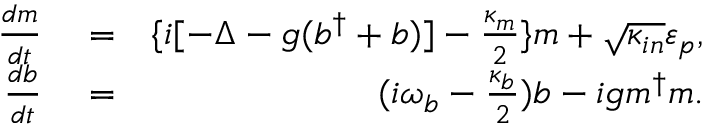<formula> <loc_0><loc_0><loc_500><loc_500>\begin{array} { r l r } { \frac { d m } { d t } } & = } & { \{ i [ - \Delta - g ( b ^ { \dagger } + b ) ] - \frac { \kappa _ { m } } { 2 } \} m + \sqrt { \kappa _ { i n } } \varepsilon _ { p } , } \\ { \frac { d b } { d t } } & = } & { ( i \omega _ { b } - \frac { \kappa _ { b } } { 2 } ) b - i g m ^ { \dagger } m . } \end{array}</formula> 